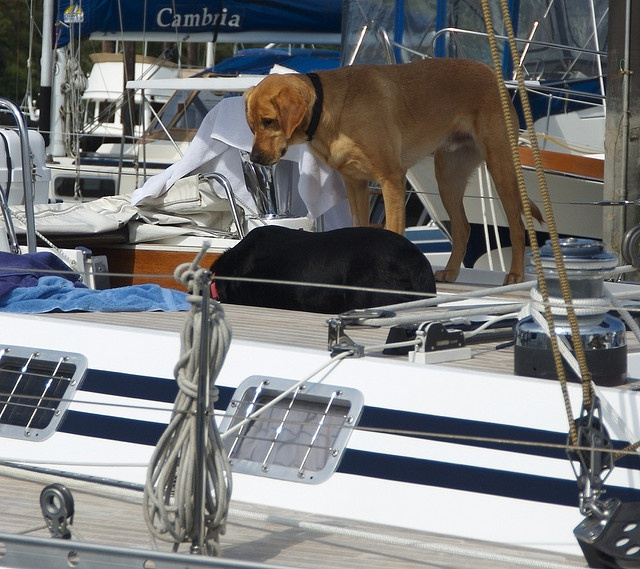Describe the objects in this image and their specific colors. I can see boat in black, white, darkgray, and gray tones, dog in black, maroon, and brown tones, boat in black, gray, darkgray, and lightgray tones, boat in black, gray, and darkgray tones, and dog in black, gray, and darkgray tones in this image. 